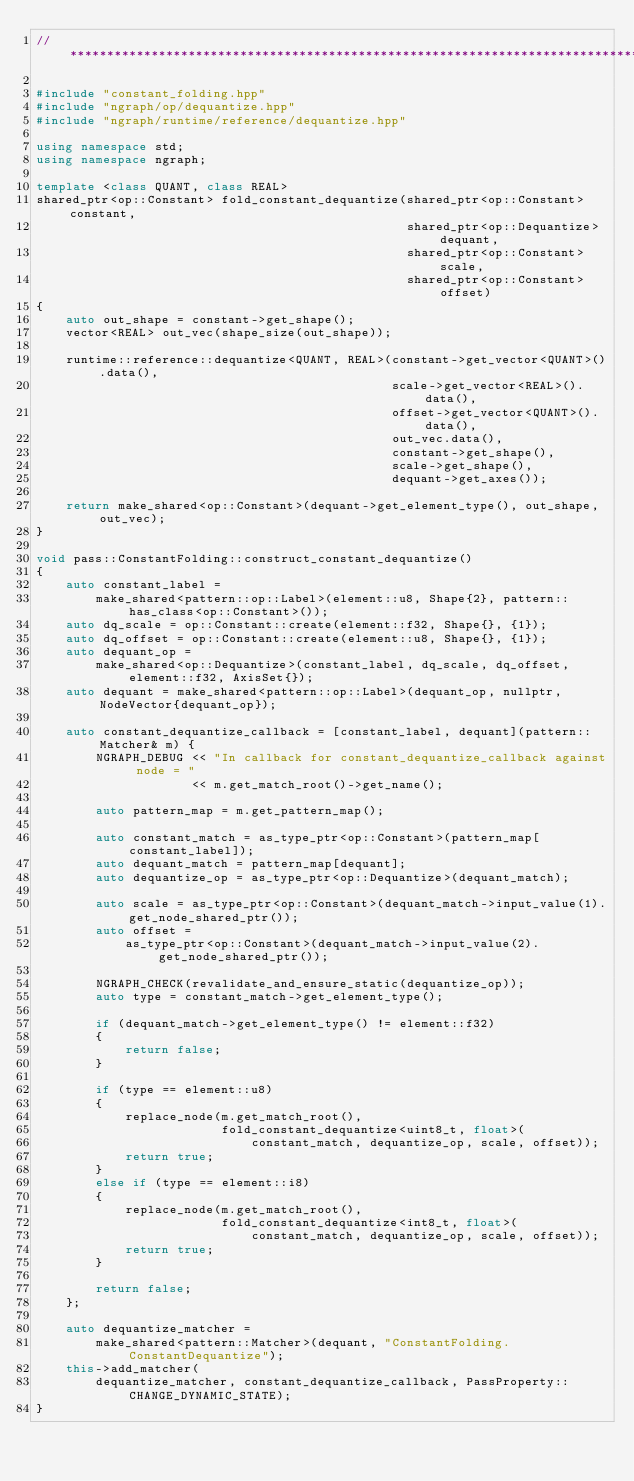<code> <loc_0><loc_0><loc_500><loc_500><_C++_>//*****************************************************************************

#include "constant_folding.hpp"
#include "ngraph/op/dequantize.hpp"
#include "ngraph/runtime/reference/dequantize.hpp"

using namespace std;
using namespace ngraph;

template <class QUANT, class REAL>
shared_ptr<op::Constant> fold_constant_dequantize(shared_ptr<op::Constant> constant,
                                                  shared_ptr<op::Dequantize> dequant,
                                                  shared_ptr<op::Constant> scale,
                                                  shared_ptr<op::Constant> offset)
{
    auto out_shape = constant->get_shape();
    vector<REAL> out_vec(shape_size(out_shape));

    runtime::reference::dequantize<QUANT, REAL>(constant->get_vector<QUANT>().data(),
                                                scale->get_vector<REAL>().data(),
                                                offset->get_vector<QUANT>().data(),
                                                out_vec.data(),
                                                constant->get_shape(),
                                                scale->get_shape(),
                                                dequant->get_axes());

    return make_shared<op::Constant>(dequant->get_element_type(), out_shape, out_vec);
}

void pass::ConstantFolding::construct_constant_dequantize()
{
    auto constant_label =
        make_shared<pattern::op::Label>(element::u8, Shape{2}, pattern::has_class<op::Constant>());
    auto dq_scale = op::Constant::create(element::f32, Shape{}, {1});
    auto dq_offset = op::Constant::create(element::u8, Shape{}, {1});
    auto dequant_op =
        make_shared<op::Dequantize>(constant_label, dq_scale, dq_offset, element::f32, AxisSet{});
    auto dequant = make_shared<pattern::op::Label>(dequant_op, nullptr, NodeVector{dequant_op});

    auto constant_dequantize_callback = [constant_label, dequant](pattern::Matcher& m) {
        NGRAPH_DEBUG << "In callback for constant_dequantize_callback against node = "
                     << m.get_match_root()->get_name();

        auto pattern_map = m.get_pattern_map();

        auto constant_match = as_type_ptr<op::Constant>(pattern_map[constant_label]);
        auto dequant_match = pattern_map[dequant];
        auto dequantize_op = as_type_ptr<op::Dequantize>(dequant_match);

        auto scale = as_type_ptr<op::Constant>(dequant_match->input_value(1).get_node_shared_ptr());
        auto offset =
            as_type_ptr<op::Constant>(dequant_match->input_value(2).get_node_shared_ptr());

        NGRAPH_CHECK(revalidate_and_ensure_static(dequantize_op));
        auto type = constant_match->get_element_type();

        if (dequant_match->get_element_type() != element::f32)
        {
            return false;
        }

        if (type == element::u8)
        {
            replace_node(m.get_match_root(),
                         fold_constant_dequantize<uint8_t, float>(
                             constant_match, dequantize_op, scale, offset));
            return true;
        }
        else if (type == element::i8)
        {
            replace_node(m.get_match_root(),
                         fold_constant_dequantize<int8_t, float>(
                             constant_match, dequantize_op, scale, offset));
            return true;
        }

        return false;
    };

    auto dequantize_matcher =
        make_shared<pattern::Matcher>(dequant, "ConstantFolding.ConstantDequantize");
    this->add_matcher(
        dequantize_matcher, constant_dequantize_callback, PassProperty::CHANGE_DYNAMIC_STATE);
}
</code> 